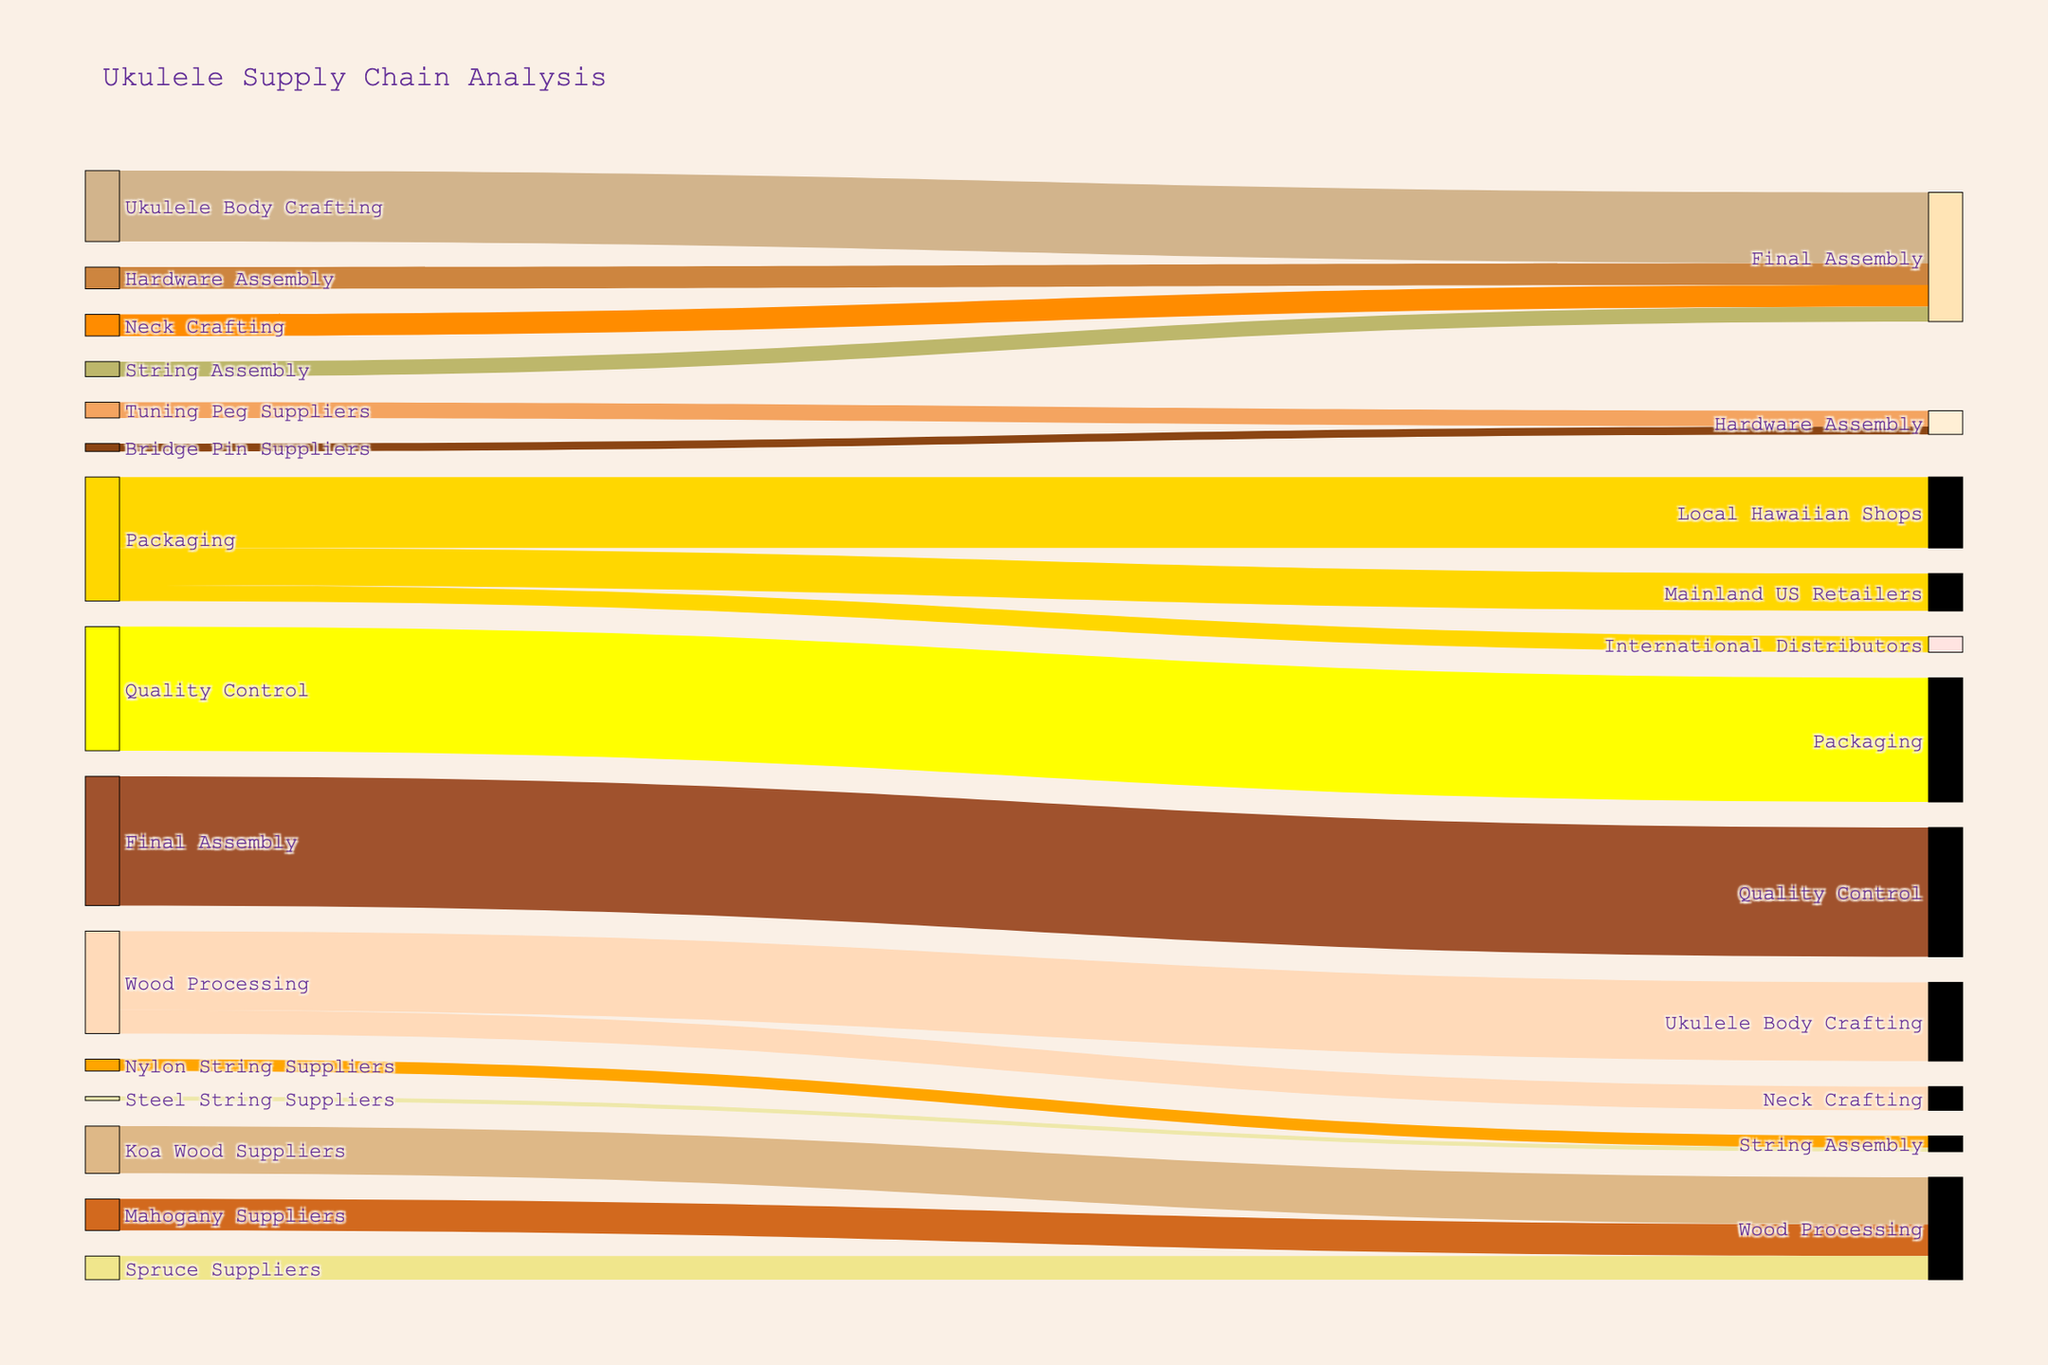What is the title of the Sankey diagram? The title can be seen directly at the top of the diagram, which serves as a summary of what the diagram represents.
Answer: Ukulele Supply Chain Analysis What is the combined value of wood being processed from Koa, Mahogany, and Spruce suppliers? To get the combined value, sum up the individual values from Koa, Mahogany, and Spruce suppliers: 1200 (Koa) + 800 (Mahogany) + 600 (Spruce).
Answer: 2600 Which component contributes the highest value to the Final Assembly stage? Examine the arrows leading into the Final Assembly stage and identify the component with the largest numerical value. Ukulele Body Crafting contributes 1800, Neck Crafting 550, String Assembly 380, Hardware Assembly 550.
Answer: Ukulele Body Crafting How does the value of Nylon String Suppliers compare to Steel String Suppliers? Compare the values directly from the diagram where Nylon String Suppliers contribute 300 and Steel String Suppliers contribute 100.
Answer: Nylon String Suppliers have a higher value What percentage of the Packaging output goes to Local Hawaiian Shops? Determine the fraction of the Packaging output that goes to Local Hawaiian Shops and convert it to a percentage. The values are 1800 (Local Hawaiian Shops), 950 (Mainland US Retailers), and 400 (International Distributors). First, find the total output: 1800 + 950 + 400 = 3150. Then, calculate the percentage: (1800 / 3150) * 100 ≈ 57.14%.
Answer: 57.14% Which stage sees the transition of the highest total value? This requires examining all stages and summing their input or output values to determine which stage handles the highest total value. Wood Processing receives a total of 2600, Ukulele Body Crafting and Final Assembly both handle 1800+550+380+550=3280, etc. The final assembly stage sees 3280.
Answer: Final Assembly Is the value flowing into Quality Control more, less, or equal to the value flowing out of Final Assembly? Compare the numerical values directly; Final Assembly to Quality Control is 3280, and Quality Control to Packaging is 3150.
Answer: Equal What is the value difference between Mahogany Suppliers and Spruce Suppliers? Subtract the value of Spruce Suppliers from Mahogany Suppliers: 800 (Mahogany) - 600 (Spruce).
Answer: 200 What proportion of the processed wood goes to Ukulele Body Crafting versus Neck Crafting? Divide the values leading to each crafting from Wood Processing and express as a proportion: 2000 (Ukulele Body Crafting) and 600 (Neck Crafting). The total is 2000 + 600 = 2600, then calculate the proportions: Ukulele Body Crafting = 2000/2600 ≈ 0.769, Neck Crafting = 600/2600 ≈ 0.231.
Answer: 76.9% to Ukulele Body Crafting, 23.1% to Neck Crafting By how much does the value from Packaging to Local Hawaiian Shops exceed the value to International Distributors? Subtract the value going to International Distributors from the value going to Local Hawaiian Shops: 1800 - 400.
Answer: 1400 